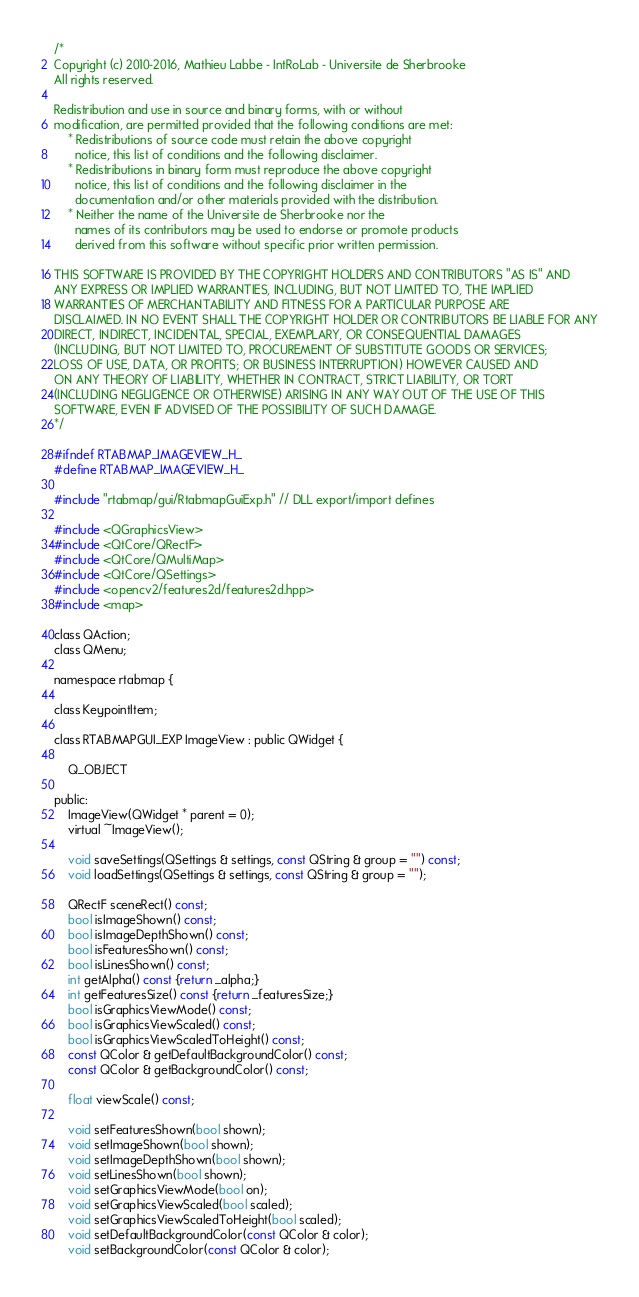Convert code to text. <code><loc_0><loc_0><loc_500><loc_500><_C_>/*
Copyright (c) 2010-2016, Mathieu Labbe - IntRoLab - Universite de Sherbrooke
All rights reserved.

Redistribution and use in source and binary forms, with or without
modification, are permitted provided that the following conditions are met:
    * Redistributions of source code must retain the above copyright
      notice, this list of conditions and the following disclaimer.
    * Redistributions in binary form must reproduce the above copyright
      notice, this list of conditions and the following disclaimer in the
      documentation and/or other materials provided with the distribution.
    * Neither the name of the Universite de Sherbrooke nor the
      names of its contributors may be used to endorse or promote products
      derived from this software without specific prior written permission.

THIS SOFTWARE IS PROVIDED BY THE COPYRIGHT HOLDERS AND CONTRIBUTORS "AS IS" AND
ANY EXPRESS OR IMPLIED WARRANTIES, INCLUDING, BUT NOT LIMITED TO, THE IMPLIED
WARRANTIES OF MERCHANTABILITY AND FITNESS FOR A PARTICULAR PURPOSE ARE
DISCLAIMED. IN NO EVENT SHALL THE COPYRIGHT HOLDER OR CONTRIBUTORS BE LIABLE FOR ANY
DIRECT, INDIRECT, INCIDENTAL, SPECIAL, EXEMPLARY, OR CONSEQUENTIAL DAMAGES
(INCLUDING, BUT NOT LIMITED TO, PROCUREMENT OF SUBSTITUTE GOODS OR SERVICES;
LOSS OF USE, DATA, OR PROFITS; OR BUSINESS INTERRUPTION) HOWEVER CAUSED AND
ON ANY THEORY OF LIABILITY, WHETHER IN CONTRACT, STRICT LIABILITY, OR TORT
(INCLUDING NEGLIGENCE OR OTHERWISE) ARISING IN ANY WAY OUT OF THE USE OF THIS
SOFTWARE, EVEN IF ADVISED OF THE POSSIBILITY OF SUCH DAMAGE.
*/

#ifndef RTABMAP_IMAGEVIEW_H_
#define RTABMAP_IMAGEVIEW_H_

#include "rtabmap/gui/RtabmapGuiExp.h" // DLL export/import defines

#include <QGraphicsView>
#include <QtCore/QRectF>
#include <QtCore/QMultiMap>
#include <QtCore/QSettings>
#include <opencv2/features2d/features2d.hpp>
#include <map>

class QAction;
class QMenu;

namespace rtabmap {

class KeypointItem;

class RTABMAPGUI_EXP ImageView : public QWidget {

	Q_OBJECT

public:
	ImageView(QWidget * parent = 0);
	virtual ~ImageView();

	void saveSettings(QSettings & settings, const QString & group = "") const;
	void loadSettings(QSettings & settings, const QString & group = "");

	QRectF sceneRect() const;
	bool isImageShown() const;
	bool isImageDepthShown() const;
	bool isFeaturesShown() const;
	bool isLinesShown() const;
	int getAlpha() const {return _alpha;}
	int getFeaturesSize() const {return _featuresSize;}
	bool isGraphicsViewMode() const;
	bool isGraphicsViewScaled() const;
	bool isGraphicsViewScaledToHeight() const;
	const QColor & getDefaultBackgroundColor() const;
	const QColor & getBackgroundColor() const;

	float viewScale() const;

	void setFeaturesShown(bool shown);
	void setImageShown(bool shown);
	void setImageDepthShown(bool shown);
	void setLinesShown(bool shown);
	void setGraphicsViewMode(bool on);
	void setGraphicsViewScaled(bool scaled);
	void setGraphicsViewScaledToHeight(bool scaled);
	void setDefaultBackgroundColor(const QColor & color);
	void setBackgroundColor(const QColor & color);
</code> 